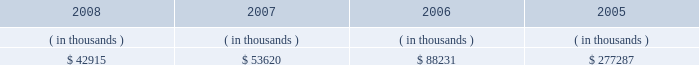System energy resources , inc .
Management's financial discussion and analysis with syndicated bank letters of credit .
In december 2004 , system energy amended these letters of credit and they now expire in may 2009 .
System energy may refinance or redeem debt prior to maturity , to the extent market conditions and interest and dividend rates are favorable .
All debt and common stock issuances by system energy require prior regulatory approval .
Debt issuances are also subject to issuance tests set forth in its bond indentures and other agreements .
System energy has sufficient capacity under these tests to meet its foreseeable capital needs .
System energy has obtained a short-term borrowing authorization from the ferc under which it may borrow , through march 31 , 2010 , up to the aggregate amount , at any one time outstanding , of $ 200 million .
See note 4 to the financial statements for further discussion of system energy's short-term borrowing limits .
System energy has also obtained an order from the ferc authorizing long-term securities issuances .
The current long- term authorization extends through june 2009 .
System energy's receivables from the money pool were as follows as of december 31 for each of the following years: .
In may 2007 , $ 22.5 million of system energy's receivable from the money pool was replaced by a note receivable from entergy new orleans .
See note 4 to the financial statements for a description of the money pool .
Nuclear matters system energy owns and operates grand gulf .
System energy is , therefore , subject to the risks related to owning and operating a nuclear plant .
These include risks from the use , storage , handling and disposal of high-level and low-level radioactive materials , regulatory requirement changes , including changes resulting from events at other plants , limitations on the amounts and types of insurance commercially available for losses in connection with nuclear operations , and technological and financial uncertainties related to decommissioning nuclear plants at the end of their licensed lives , including the sufficiency of funds in decommissioning trusts .
In the event of an unanticipated early shutdown of grand gulf , system energy may be required to provide additional funds or credit support to satisfy regulatory requirements for decommissioning .
Environmental risks system energy's facilities and operations are subject to regulation by various governmental authorities having jurisdiction over air quality , water quality , control of toxic substances and hazardous and solid wastes , and other environmental matters .
Management believes that system energy is in substantial compliance with environmental regulations currently applicable to its facilities and operations .
Because environmental regulations are subject to change , future compliance costs cannot be precisely estimated .
Critical accounting estimates the preparation of system energy's financial statements in conformity with generally accepted accounting principles requires management to apply appropriate accounting policies and to make estimates and judgments that .
What percent of system energy's receivable from the money pool was replaced by a note receivable from entergy new orleans? 
Computations: ((22.5 * 1000) / 53620)
Answer: 0.41962. 